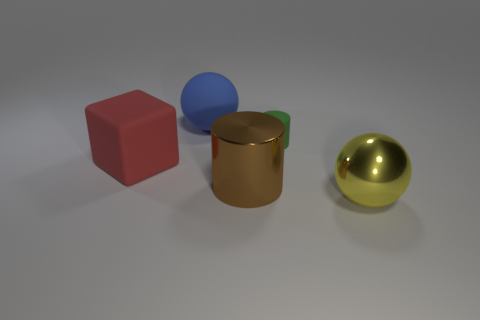Is there any indication of the size scale of these objects? There are no familiar objects or references in the image that can provide an exact scale. However, the consistency and quality of the shadows, as well as the textures on the surfaces, suggest that these objects might be relatively small, possibly akin to tabletop-size items commonly used for still life compositions in photography or illustration studies. 